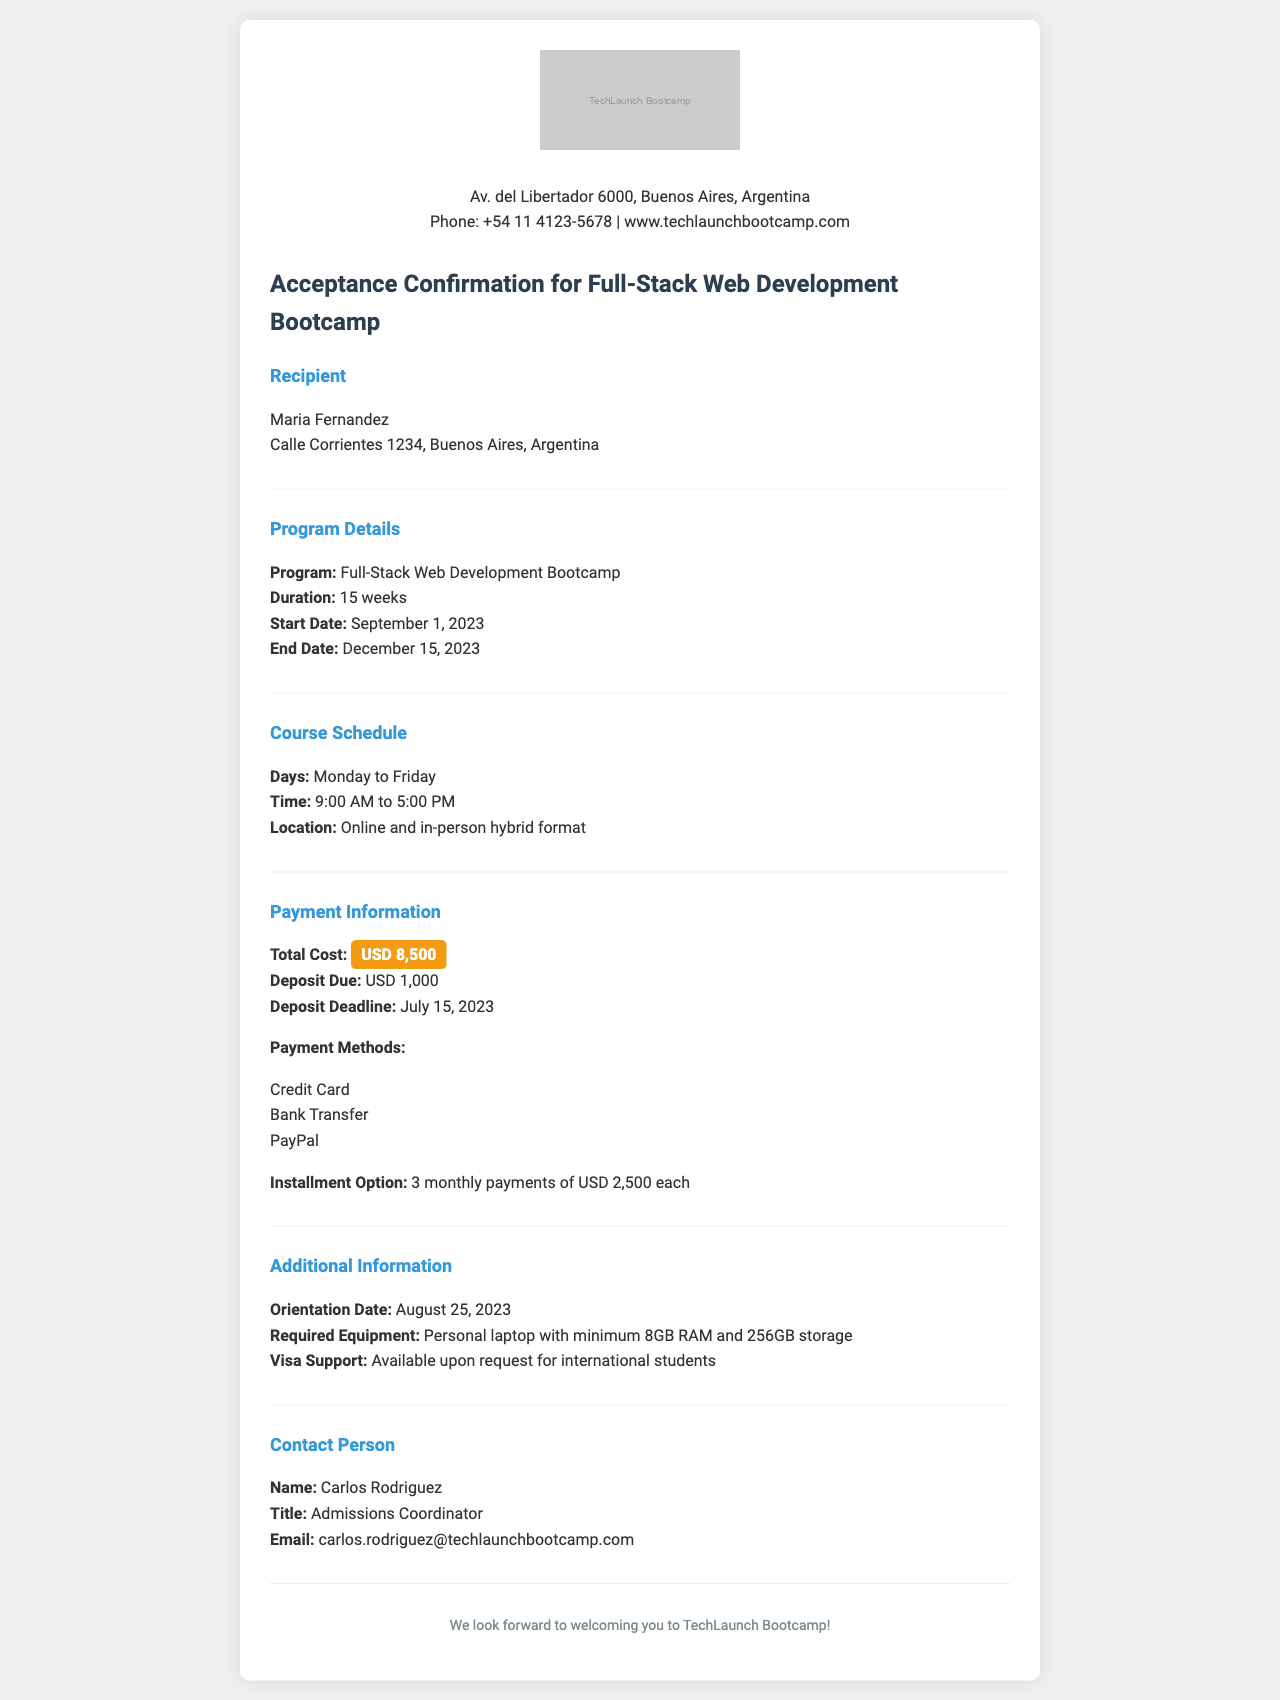What is the name of the bootcamp program? The name of the bootcamp program is provided in the document as the Full-Stack Web Development Bootcamp.
Answer: Full-Stack Web Development Bootcamp What is the total cost of the program? The document states that the total cost of the program is highlighted as USD 8,500.
Answer: USD 8,500 When does the program start? The document specifies the start date of the program as September 1, 2023.
Answer: September 1, 2023 How long is the bootcamp program? The duration of the program is mentioned in the document as 15 weeks.
Answer: 15 weeks What is the deposit deadline? The deposit deadline for the program is indicated in the document as July 15, 2023.
Answer: July 15, 2023 What is the orientation date? The orientation date given in the document is August 25, 2023.
Answer: August 25, 2023 What payment method is NOT listed? The document lists specific payment methods, and asking for a method not included would require reasoning through the listed options. For example, Cash is not mentioned.
Answer: Cash What is the location of the classes? The document describes the class location as online and in-person hybrid format.
Answer: Online and in-person hybrid format Who is the contact person for admissions? The name and title of the contact person for admissions are specified in the document.
Answer: Carlos Rodriguez 